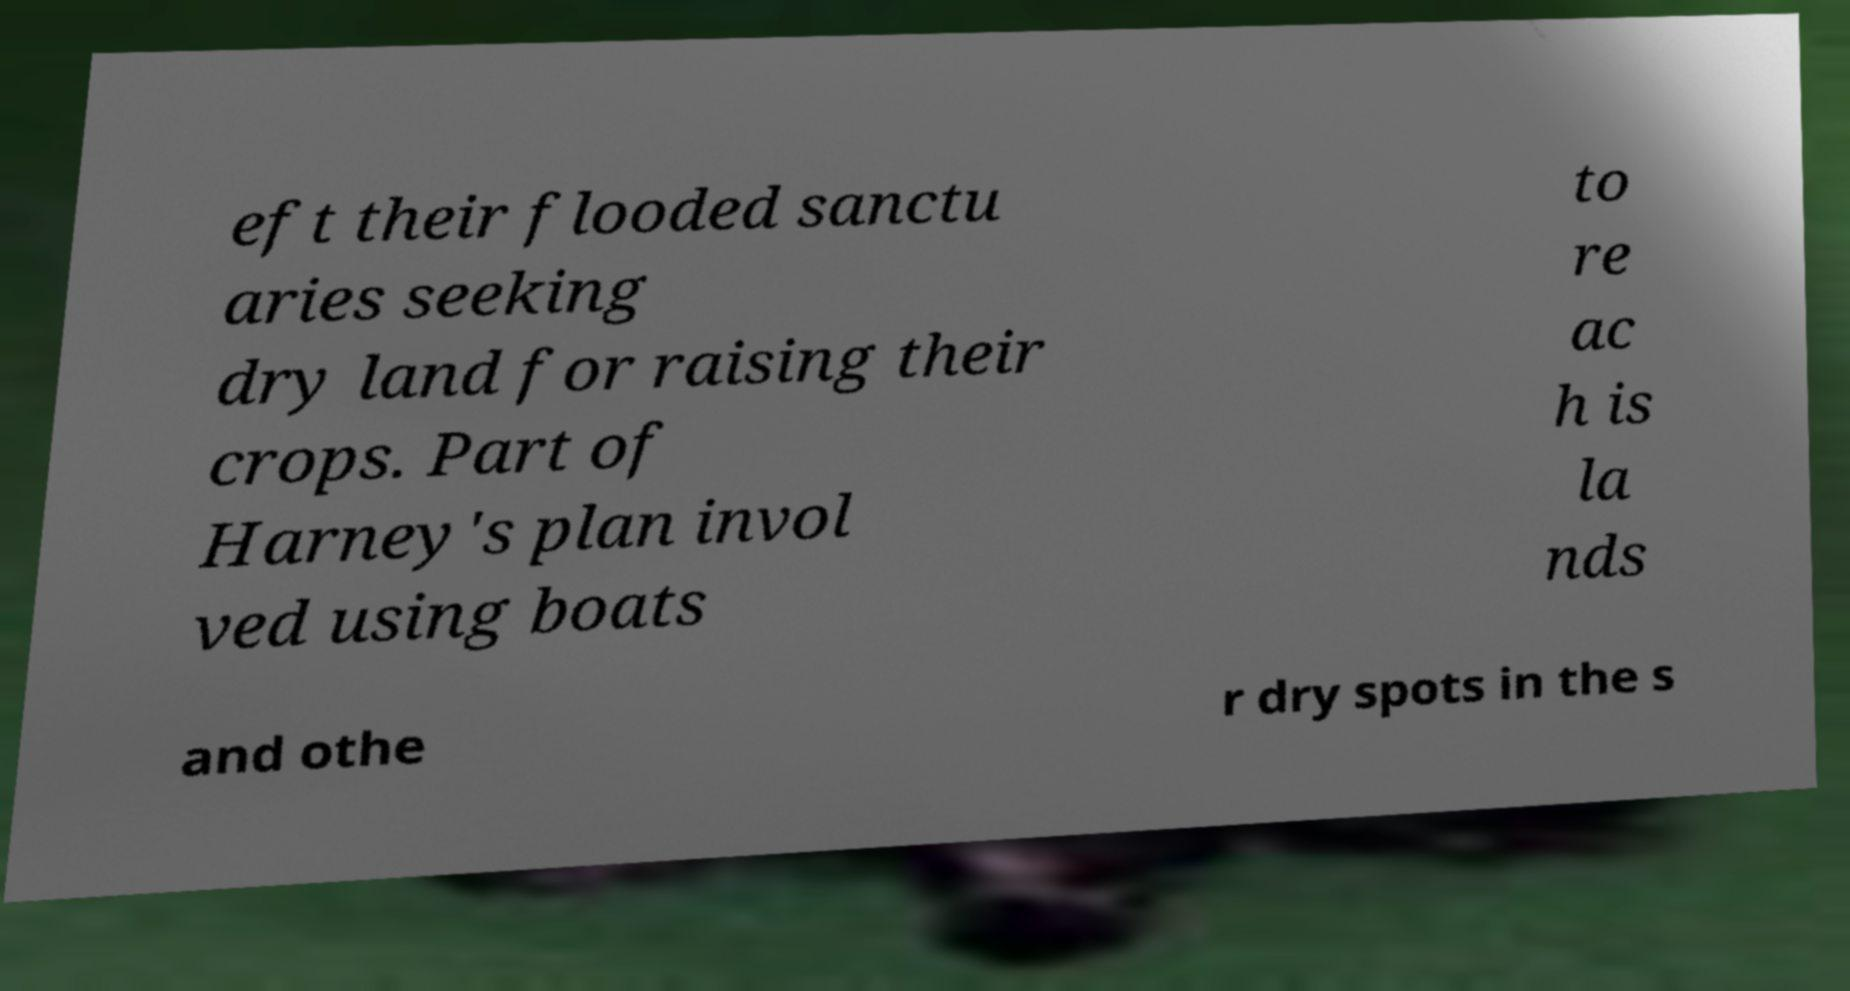For documentation purposes, I need the text within this image transcribed. Could you provide that? eft their flooded sanctu aries seeking dry land for raising their crops. Part of Harney's plan invol ved using boats to re ac h is la nds and othe r dry spots in the s 